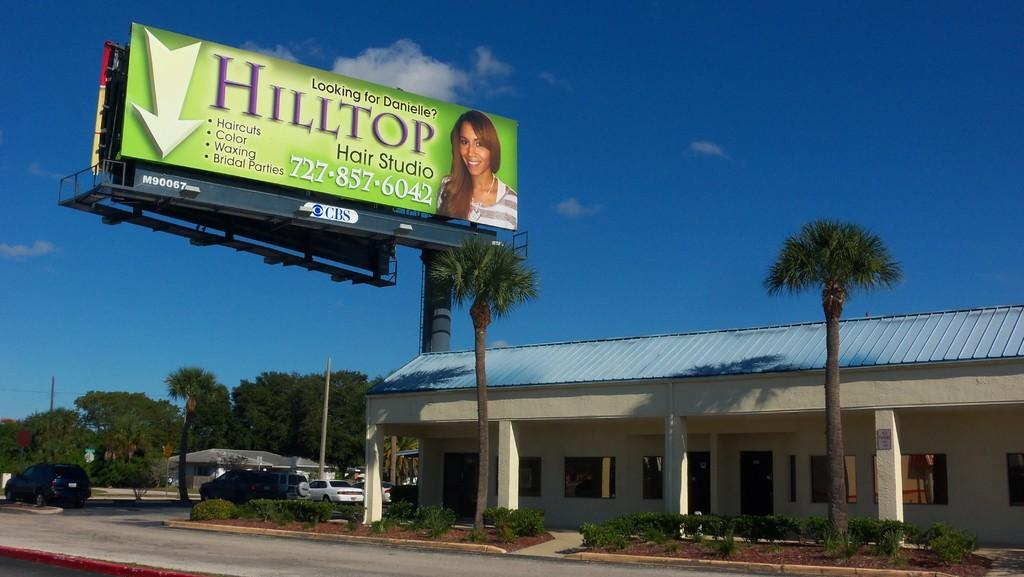<image>
Offer a succinct explanation of the picture presented. A billboard advertises a location called HILLTOP HAIR STUDIO. 